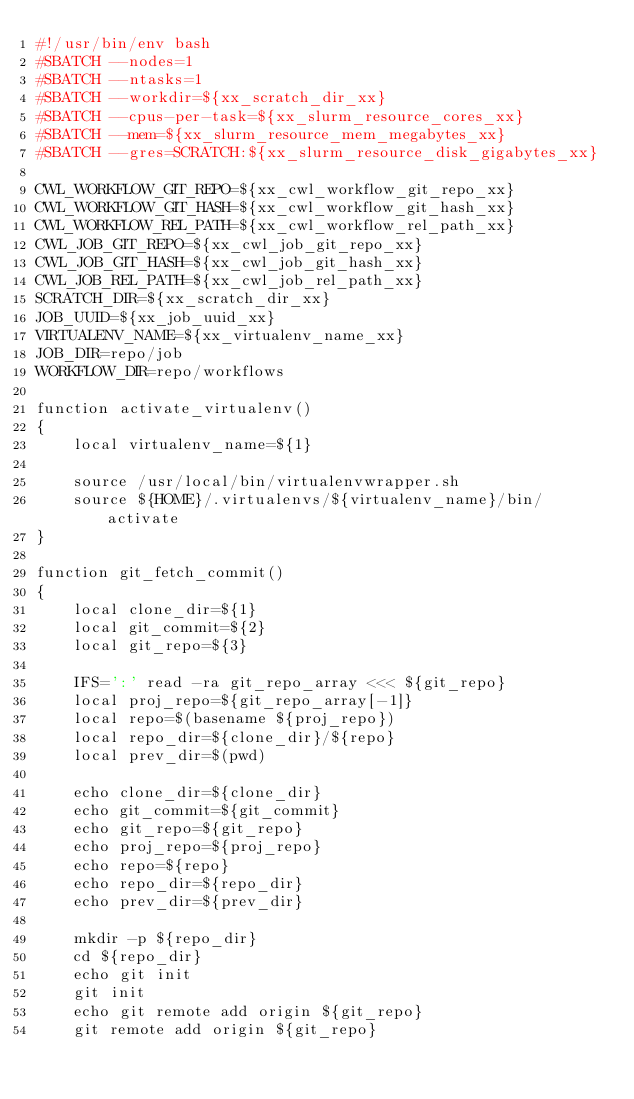<code> <loc_0><loc_0><loc_500><loc_500><_Bash_>#!/usr/bin/env bash
#SBATCH --nodes=1
#SBATCH --ntasks=1
#SBATCH --workdir=${xx_scratch_dir_xx}
#SBATCH --cpus-per-task=${xx_slurm_resource_cores_xx}
#SBATCH --mem=${xx_slurm_resource_mem_megabytes_xx}
#SBATCH --gres=SCRATCH:${xx_slurm_resource_disk_gigabytes_xx}

CWL_WORKFLOW_GIT_REPO=${xx_cwl_workflow_git_repo_xx}
CWL_WORKFLOW_GIT_HASH=${xx_cwl_workflow_git_hash_xx}
CWL_WORKFLOW_REL_PATH=${xx_cwl_workflow_rel_path_xx}
CWL_JOB_GIT_REPO=${xx_cwl_job_git_repo_xx}
CWL_JOB_GIT_HASH=${xx_cwl_job_git_hash_xx}
CWL_JOB_REL_PATH=${xx_cwl_job_rel_path_xx}
SCRATCH_DIR=${xx_scratch_dir_xx}
JOB_UUID=${xx_job_uuid_xx}
VIRTUALENV_NAME=${xx_virtualenv_name_xx}
JOB_DIR=repo/job
WORKFLOW_DIR=repo/workflows

function activate_virtualenv()
{
    local virtualenv_name=${1}

    source /usr/local/bin/virtualenvwrapper.sh
    source ${HOME}/.virtualenvs/${virtualenv_name}/bin/activate
}

function git_fetch_commit()
{
    local clone_dir=${1}
    local git_commit=${2}
    local git_repo=${3}

    IFS=':' read -ra git_repo_array <<< ${git_repo}
    local proj_repo=${git_repo_array[-1]}
    local repo=$(basename ${proj_repo})
    local repo_dir=${clone_dir}/${repo}
    local prev_dir=$(pwd)

    echo clone_dir=${clone_dir}
    echo git_commit=${git_commit}
    echo git_repo=${git_repo}
    echo proj_repo=${proj_repo}
    echo repo=${repo}
    echo repo_dir=${repo_dir}
    echo prev_dir=${prev_dir}

    mkdir -p ${repo_dir}
    cd ${repo_dir}
    echo git init
    git init
    echo git remote add origin ${git_repo}
    git remote add origin ${git_repo}</code> 